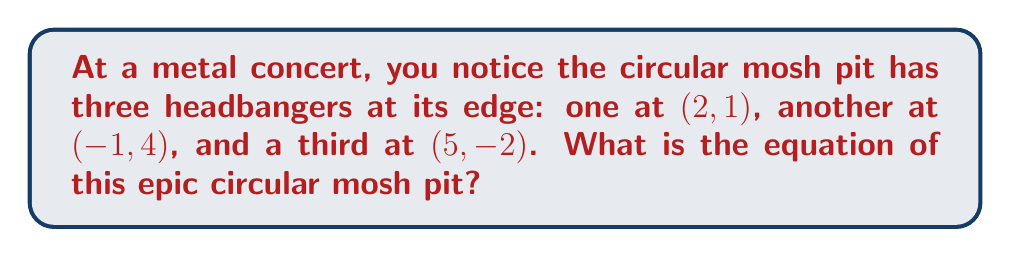Solve this math problem. Let's determine the equation of the circle step by step:

1) The general equation of a circle is:
   $$(x - h)^2 + (y - k)^2 = r^2$$
   where (h, k) is the center and r is the radius.

2) We can find the center and radius using the three given points:
   A(2, 1), B(-1, 4), and C(5, -2)

3) The center of the circle is the intersection of the perpendicular bisectors of any two chords. Let's use AB and BC.

4) Midpoint of AB: $(\frac{2-1}{2}, \frac{1+4}{2}) = (0.5, 2.5)$
   Midpoint of BC: $(\frac{-1+5}{2}, \frac{4-2}{2}) = (2, 1)$

5) Slope of AB: $m_{AB} = \frac{4-1}{-1-2} = -1$
   Slope of BC: $m_{BC} = \frac{-2-4}{5+1} = -1$

6) Perpendicular slopes: $m_{\perp AB} = 1$, $m_{\perp BC} = 1$

7) Equations of perpendicular bisectors:
   AB⊥: $y - 2.5 = 1(x - 0.5)$
   BC⊥: $y - 1 = 1(x - 2)$

8) Solving these simultaneously:
   $y = x + 2$ and $y = x - 1$
   $x + 2 = x - 1$
   $3 = 0$
   Center: (2, 3)

9) Radius: distance from center to any point, e.g., A(2, 1)
   $r = \sqrt{(2-2)^2 + (1-3)^2} = 2$

10) Therefore, the equation of the circle is:
    $$(x - 2)^2 + (y - 3)^2 = 4$$

[asy]
import geometry;

pair A = (2,1), B = (-1,4), C = (5,-2), O = (2,3);
draw(circle(O,2));
dot("A",A,SE);
dot("B",B,NW);
dot("C",C,SE);
dot("O",O,N);
[/asy]
Answer: $(x - 2)^2 + (y - 3)^2 = 4$ 